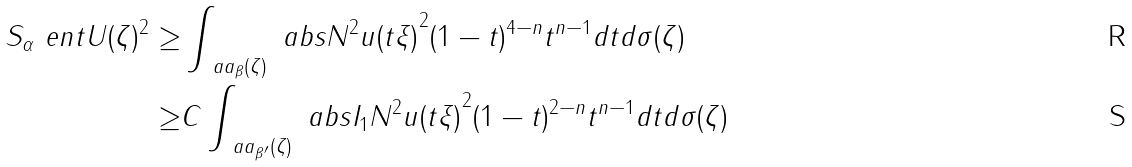<formula> <loc_0><loc_0><loc_500><loc_500>S _ { \alpha } \ e n t { U } ( \zeta ) ^ { 2 } \geq & \int _ { \ a a _ { \beta } ( \zeta ) } \ a b s { N ^ { 2 } u ( t \xi ) } ^ { 2 } ( 1 - t ) ^ { 4 - n } t ^ { n - 1 } d t d \sigma ( \zeta ) \\ \geq & C \int _ { \ a a _ { \beta ^ { \prime } } ( \zeta ) } \ a b s { I _ { 1 } N ^ { 2 } u ( t \xi ) } ^ { 2 } ( 1 - t ) ^ { 2 - n } t ^ { n - 1 } d t d \sigma ( \zeta )</formula> 